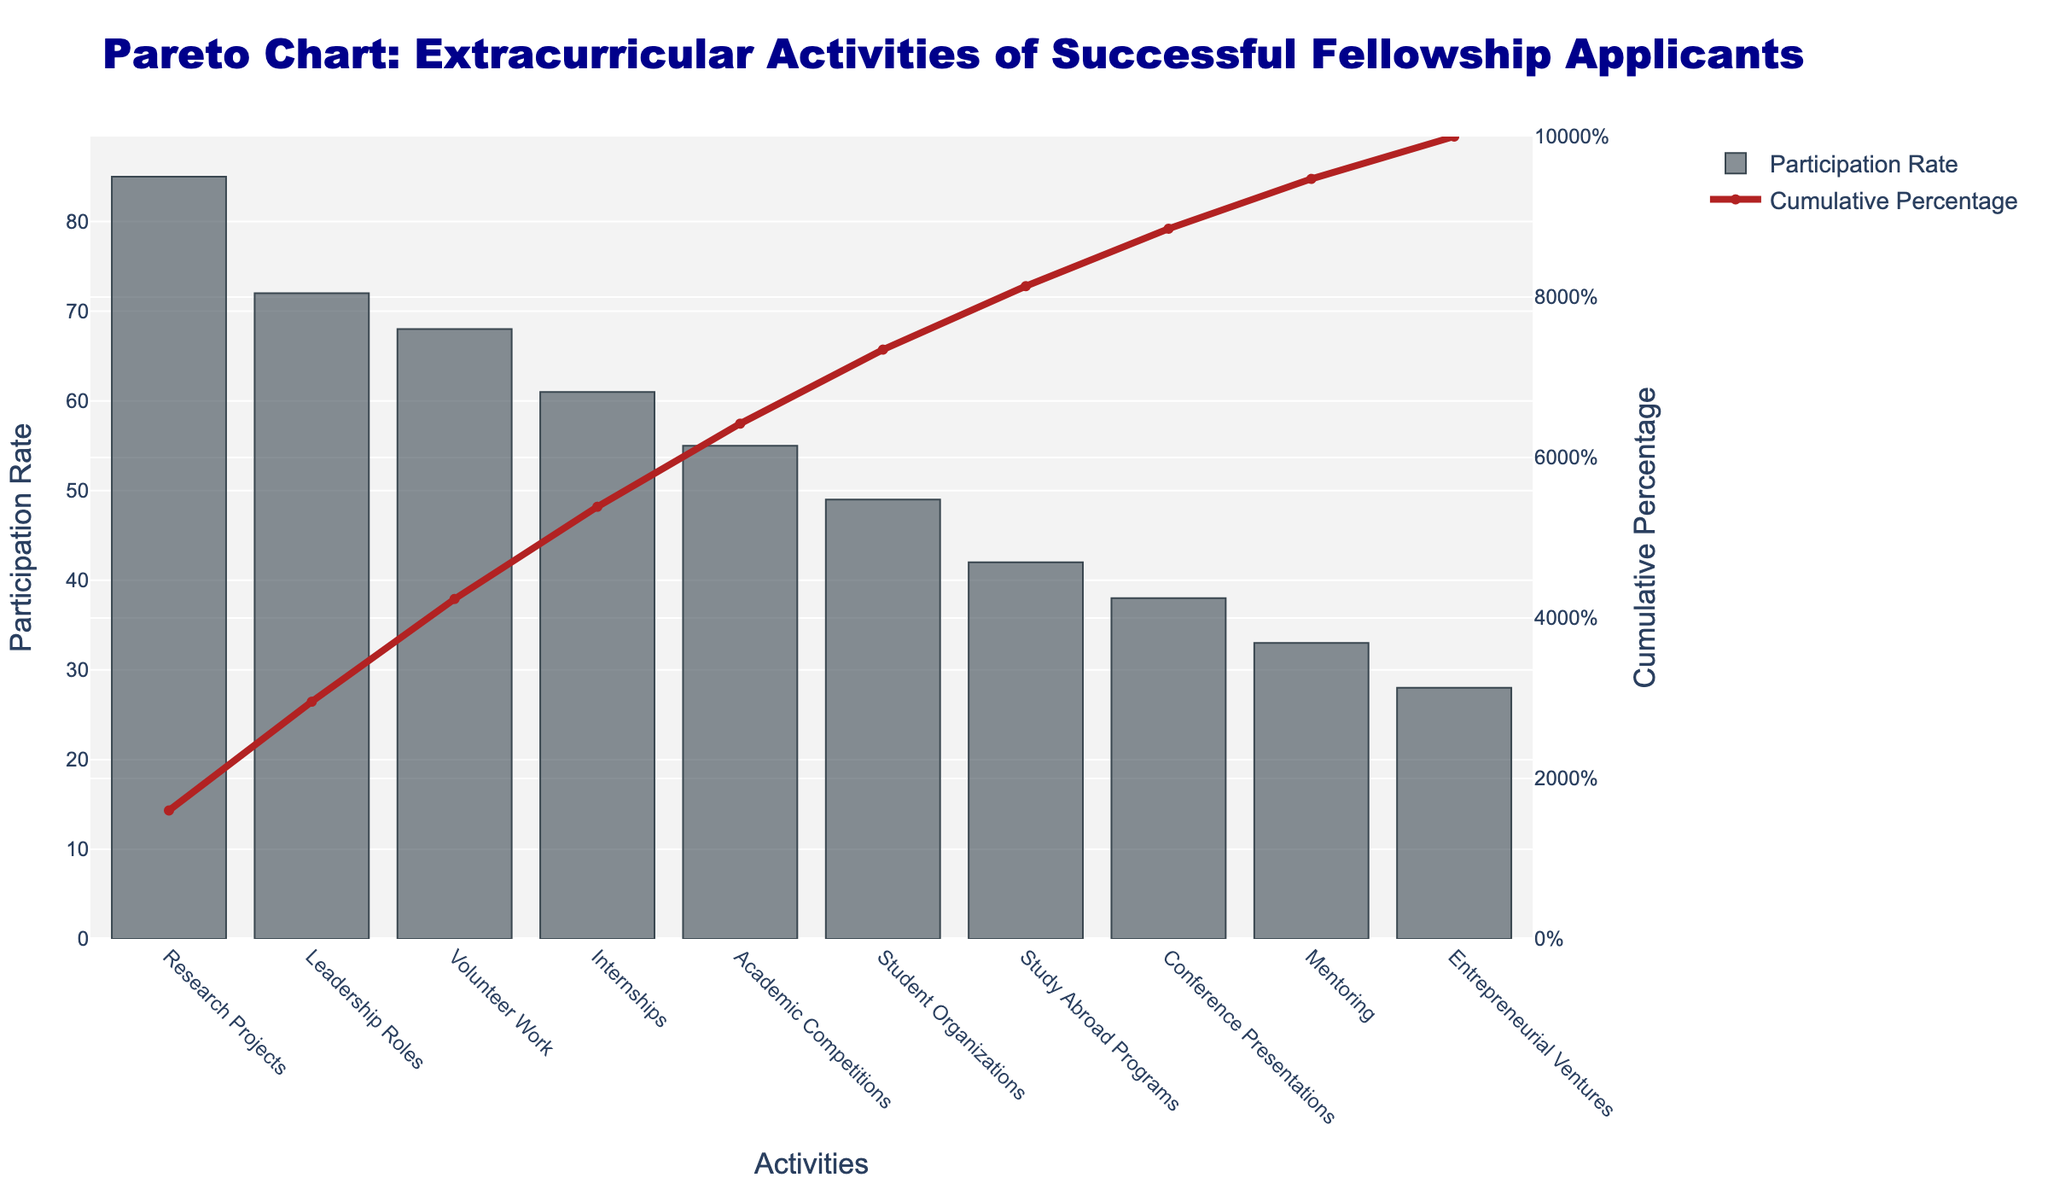what is the title of the figure? The title is located at the top of the figure. It reads "Pareto Chart: Extracurricular Activities of Successful Fellowship Applicants".
Answer: Pareto Chart: Extracurricular Activities of Successful Fellowship Applicants What is the participation rate for leadership roles? To find this, locate the bar representing Leadership Roles and read the corresponding value on the y-axis for participation rate. The participation rate for Leadership Roles is 72%.
Answer: 72% How many activities have a participation rate of over 50%? To find this, count the number of bars that extend beyond the 50% mark on the y-axis. The activities are Research Projects, Leadership Roles, Volunteer Work, Internships, and Academic Competitions.
Answer: 5 What is the cumulative participation rate for the top three activities? Sum the participation rates of Research Projects, Leadership Roles, and Volunteer Work, which are the top three activities, then verify with the cumulative percentage line for these three activities (85% + 72% + 68% = 225%). The cumulative percentage for these activities should be checked in the figure where the line passes.
Answer: 225% (Note: It would be around this figure, and can be confirmed by the cumulative line.) Which activity has the lowest participation rate, and what is it? Identify the shortest bar in the figure, which corresponds to the activity with the lowest participation rate. The activity is Entrepreneurial Ventures with a participation rate of 28%.
Answer: Entrepreneurial Ventures, 28% How much higher is the participation rate for research projects compared to academic competitions? Identify the participation rates for Research Projects (85%) and Academic Competitions (55%). The difference is 85% - 55% = 30%.
Answer: 30% What is the cumulative percentage after the first four activities? Locate the cumulative percentage for the first four activities (Research Projects, Leadership Roles, Volunteer Work, Internships). Refer to the Cumulative Percentage Line at the fourth activity marker – it is approximately 286 (85 + 72 + 68 + 61) / 409 = 69.92
Answer: About 70% By what percentage does the volunteer work participation rate exceed mentoring? Find and compare the participation rates of Volunteer Work (68%) and Mentoring (33%). The difference is 68% - 33% = 35%.
Answer: 35% Which activity marks the point where the cumulative percentage exceeds 50%? Identify the activity where the cumulative percentage line crosses the 50% mark. This occurs right after Leadership Roles.
Answer: Leadership Roles What is the relative difference in percentage participation between study abroad programs and student organizations? Find the participation rates for Study Abroad Programs (42%) and Student Organizations (49%). The relative difference is (49 - 42) / 42 * 100%. This equals approximately 16.67%.
Answer: About 16.67% 